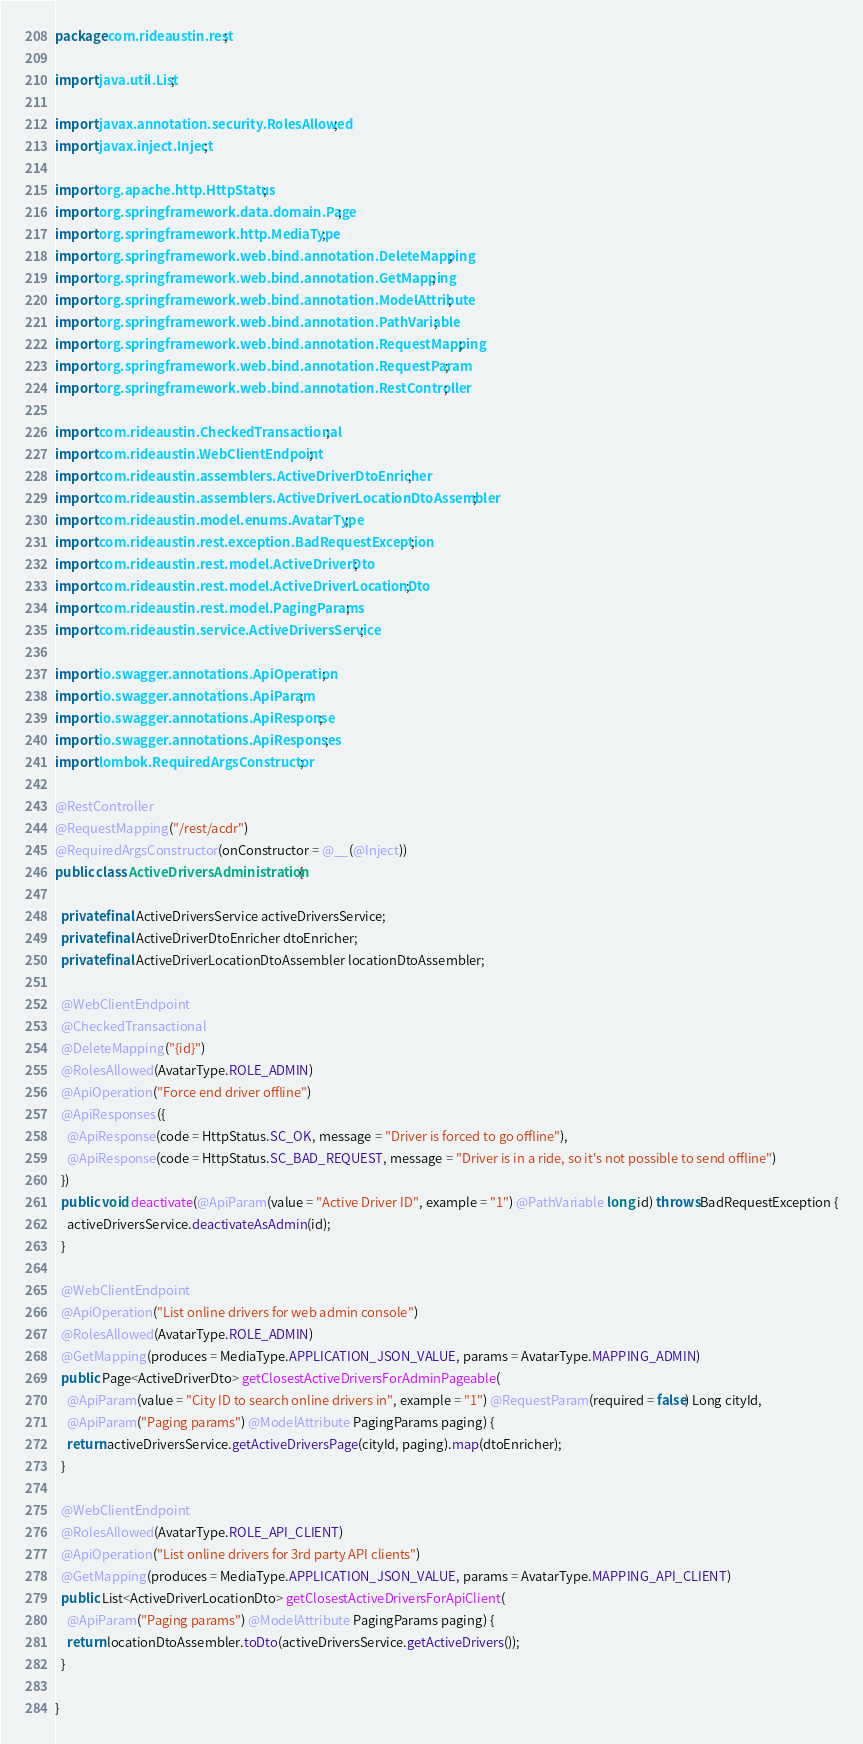Convert code to text. <code><loc_0><loc_0><loc_500><loc_500><_Java_>package com.rideaustin.rest;

import java.util.List;

import javax.annotation.security.RolesAllowed;
import javax.inject.Inject;

import org.apache.http.HttpStatus;
import org.springframework.data.domain.Page;
import org.springframework.http.MediaType;
import org.springframework.web.bind.annotation.DeleteMapping;
import org.springframework.web.bind.annotation.GetMapping;
import org.springframework.web.bind.annotation.ModelAttribute;
import org.springframework.web.bind.annotation.PathVariable;
import org.springframework.web.bind.annotation.RequestMapping;
import org.springframework.web.bind.annotation.RequestParam;
import org.springframework.web.bind.annotation.RestController;

import com.rideaustin.CheckedTransactional;
import com.rideaustin.WebClientEndpoint;
import com.rideaustin.assemblers.ActiveDriverDtoEnricher;
import com.rideaustin.assemblers.ActiveDriverLocationDtoAssembler;
import com.rideaustin.model.enums.AvatarType;
import com.rideaustin.rest.exception.BadRequestException;
import com.rideaustin.rest.model.ActiveDriverDto;
import com.rideaustin.rest.model.ActiveDriverLocationDto;
import com.rideaustin.rest.model.PagingParams;
import com.rideaustin.service.ActiveDriversService;

import io.swagger.annotations.ApiOperation;
import io.swagger.annotations.ApiParam;
import io.swagger.annotations.ApiResponse;
import io.swagger.annotations.ApiResponses;
import lombok.RequiredArgsConstructor;

@RestController
@RequestMapping("/rest/acdr")
@RequiredArgsConstructor(onConstructor = @__(@Inject))
public class ActiveDriversAdministration {

  private final ActiveDriversService activeDriversService;
  private final ActiveDriverDtoEnricher dtoEnricher;
  private final ActiveDriverLocationDtoAssembler locationDtoAssembler;

  @WebClientEndpoint
  @CheckedTransactional
  @DeleteMapping("{id}")
  @RolesAllowed(AvatarType.ROLE_ADMIN)
  @ApiOperation("Force end driver offline")
  @ApiResponses({
    @ApiResponse(code = HttpStatus.SC_OK, message = "Driver is forced to go offline"),
    @ApiResponse(code = HttpStatus.SC_BAD_REQUEST, message = "Driver is in a ride, so it's not possible to send offline")
  })
  public void deactivate(@ApiParam(value = "Active Driver ID", example = "1") @PathVariable long id) throws BadRequestException {
    activeDriversService.deactivateAsAdmin(id);
  }

  @WebClientEndpoint
  @ApiOperation("List online drivers for web admin console")
  @RolesAllowed(AvatarType.ROLE_ADMIN)
  @GetMapping(produces = MediaType.APPLICATION_JSON_VALUE, params = AvatarType.MAPPING_ADMIN)
  public Page<ActiveDriverDto> getClosestActiveDriversForAdminPageable(
    @ApiParam(value = "City ID to search online drivers in", example = "1") @RequestParam(required = false) Long cityId,
    @ApiParam("Paging params") @ModelAttribute PagingParams paging) {
    return activeDriversService.getActiveDriversPage(cityId, paging).map(dtoEnricher);
  }

  @WebClientEndpoint
  @RolesAllowed(AvatarType.ROLE_API_CLIENT)
  @ApiOperation("List online drivers for 3rd party API clients")
  @GetMapping(produces = MediaType.APPLICATION_JSON_VALUE, params = AvatarType.MAPPING_API_CLIENT)
  public List<ActiveDriverLocationDto> getClosestActiveDriversForApiClient(
    @ApiParam("Paging params") @ModelAttribute PagingParams paging) {
    return locationDtoAssembler.toDto(activeDriversService.getActiveDrivers());
  }

}
</code> 